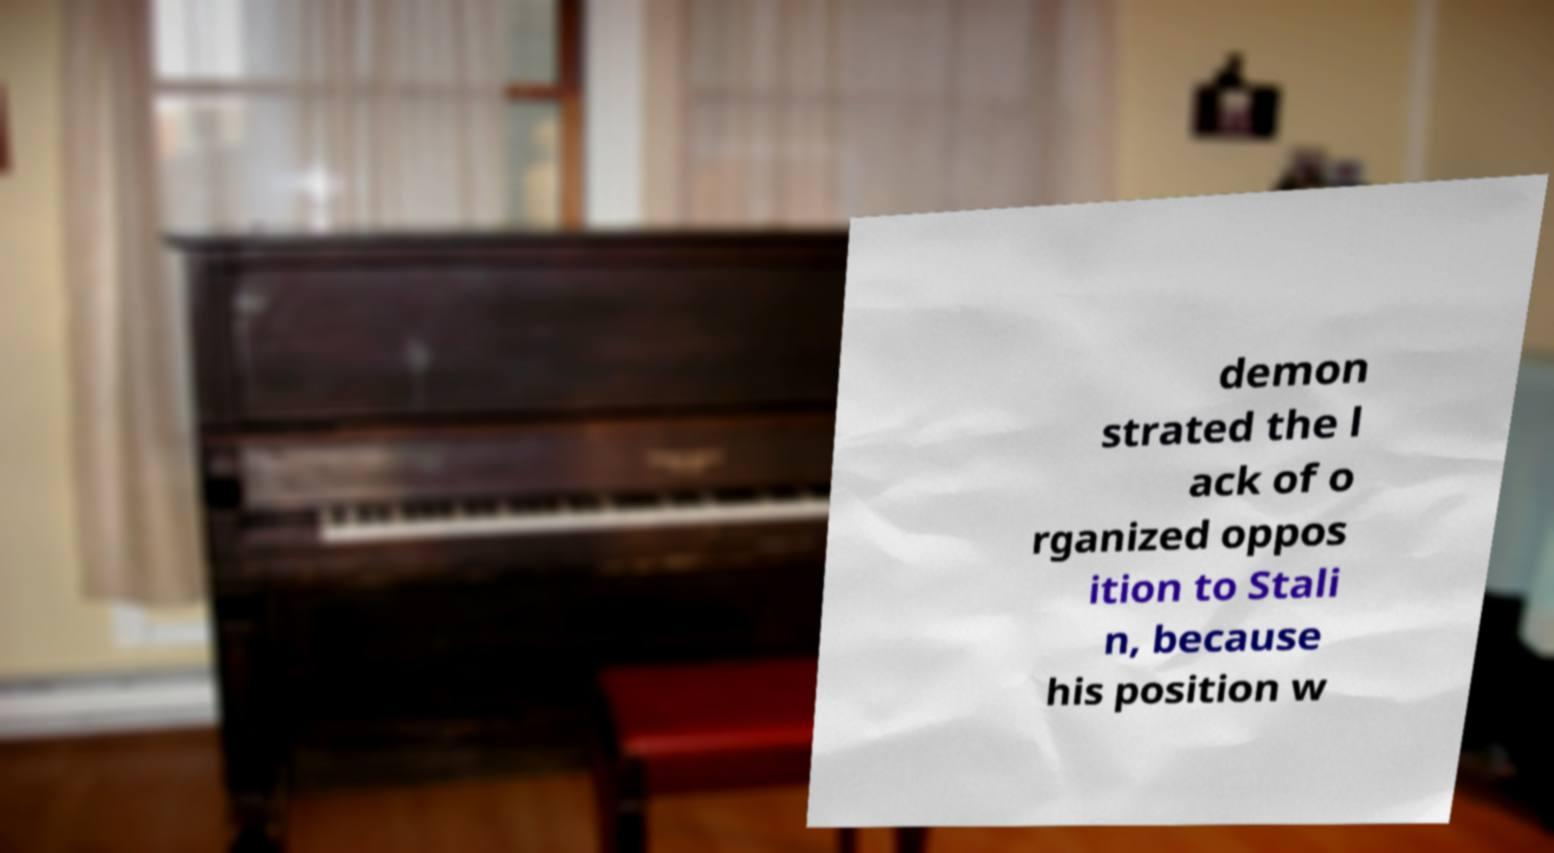Could you extract and type out the text from this image? demon strated the l ack of o rganized oppos ition to Stali n, because his position w 